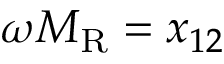Convert formula to latex. <formula><loc_0><loc_0><loc_500><loc_500>\omega M _ { R } = x _ { 1 2 }</formula> 